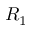<formula> <loc_0><loc_0><loc_500><loc_500>R _ { 1 }</formula> 